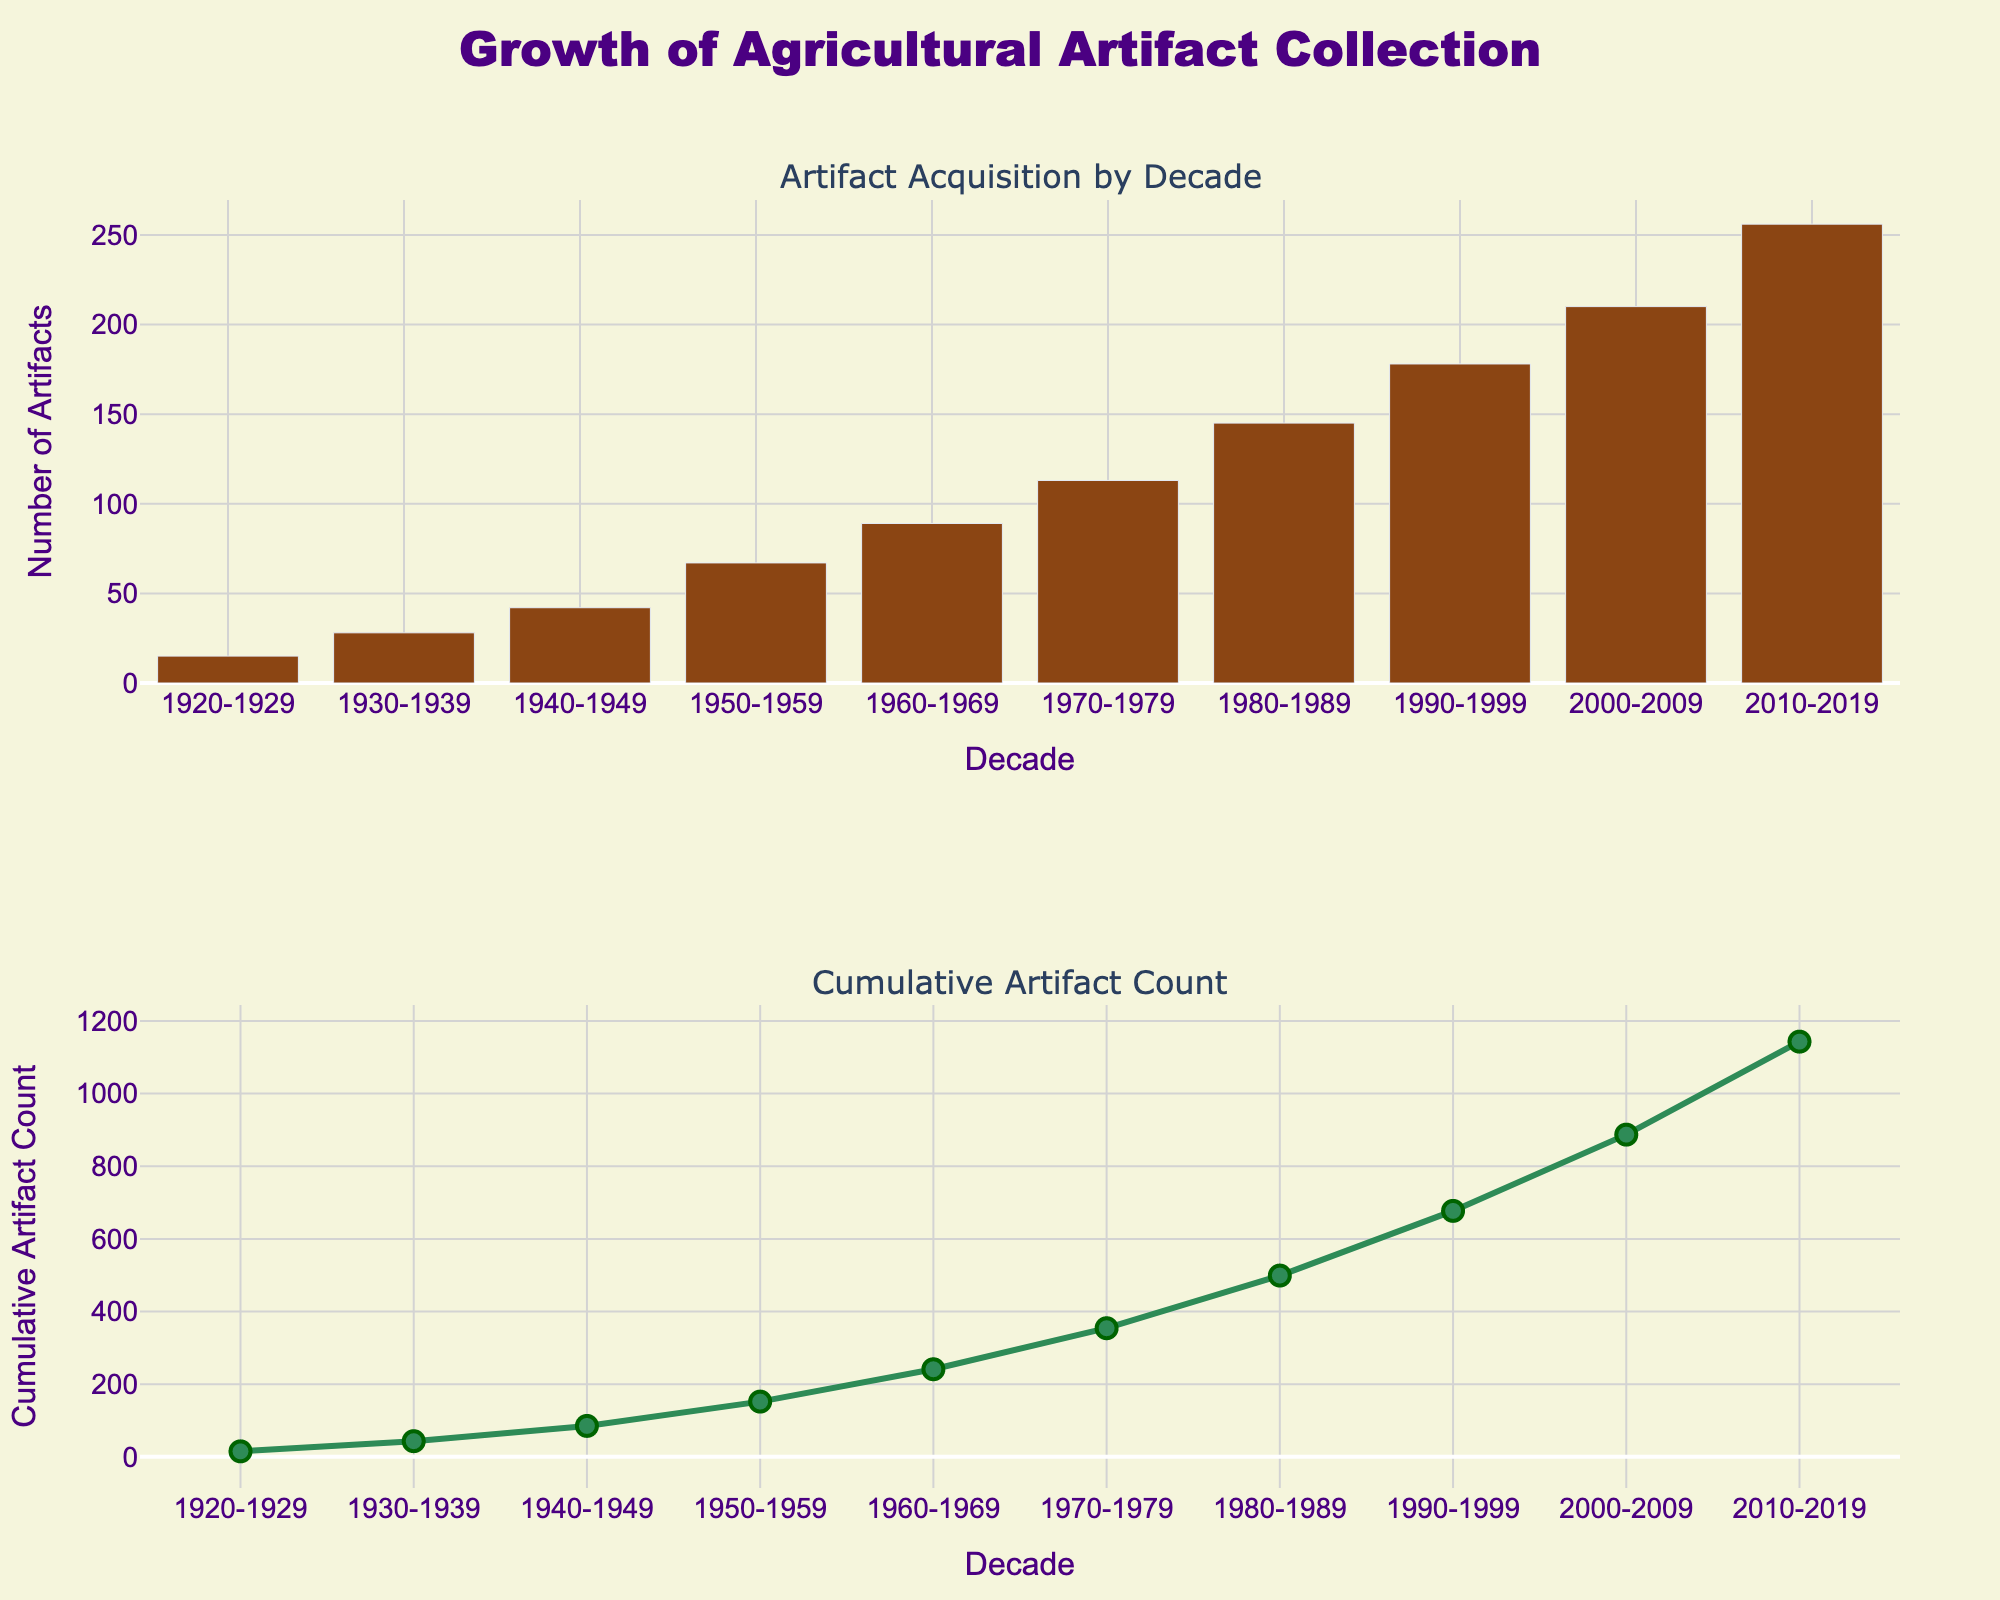What's the title of the figure? The overall title of the figure is displayed at the top of the plot area. The title helps in identifying the subject and intention of the figure.
Answer: Growth of Agricultural Artifact Collection What does the first subplot represent? To understand the message conveyed by the figure, check the subplot title and the visual content. The first subplot's title is above it, and the content is a bar plot showing counts.
Answer: Artifact Acquisition by Decade What does the second subplot represent? The title above the second subplot indicates its purpose. This, combined with the content which is a line plot, provides insight into cumulative data visualization.
Answer: Cumulative Artifact Count What color is used for the bars in the first subplot? Observing the bars and the figure's design details, it's clear that a specific color is consistently used for all bars.
Answer: Brown What color is used for the line in the second subplot? The line's color in the second subplot is easily noticeable because it's consistently applied.
Answer: Green Between which decades did the artifact count increase the most? To determine this, look at the height difference in bars between each consecutive decade. The greatest visual difference indicates the highest increase.
Answer: 1950-1959 to 1960-1969 From the first subplot, during which decade did the museum acquire only 15 artifacts? The first subplot's bars correspond to each decade and display the acquisition counts. Identify the bar that shows a count of 15 artifacts.
Answer: 1920-1929 What is the total number of artifacts acquired from 1920 to 2019? Add the counts from all decades shown in the first subplot. Each bar on the histogram represents the count for a respective decade.
Answer: 1143 How many artifacts were acquired between 1960 and 1969? Find the bar corresponding to the 1960-1969 decade and check the labeled count from the first subplot.
Answer: 89 What is the cumulative count by the end of 2010-2019? The cumulative count plot shows the increasing total. By the end of the last point on the line corresponding to 2010-2019, the total is displayed.
Answer: 1143 Which decade shows the first major increase in artifact acquisition? Examine the first histogram to see where the initial notable rise occurs in artifact acquisition counts from one decade to the next.
Answer: 1930-1939 